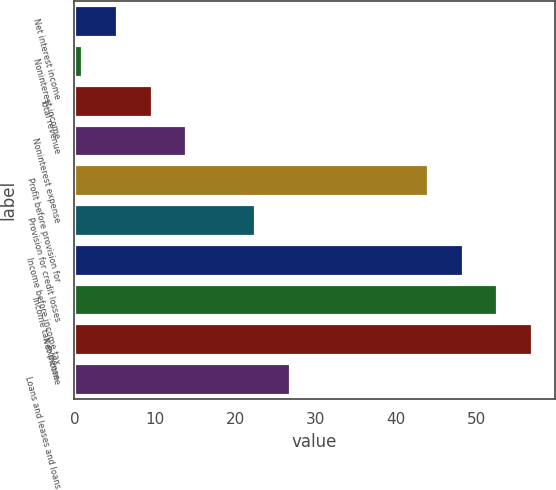<chart> <loc_0><loc_0><loc_500><loc_500><bar_chart><fcel>Net interest income<fcel>Noninterest income<fcel>Total revenue<fcel>Noninterest expense<fcel>Profit before provision for<fcel>Provision for credit losses<fcel>Income before income tax<fcel>Income tax expense<fcel>Net income<fcel>Loans and leases and loans<nl><fcel>5.3<fcel>1<fcel>9.6<fcel>13.9<fcel>44<fcel>22.5<fcel>48.3<fcel>52.6<fcel>56.9<fcel>26.8<nl></chart> 